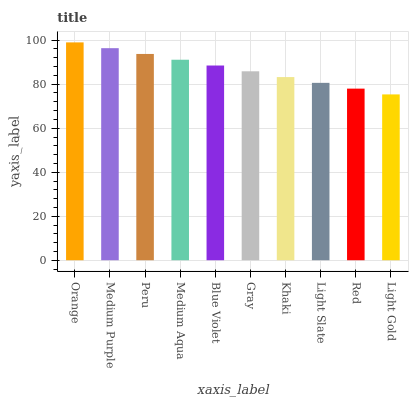Is Light Gold the minimum?
Answer yes or no. Yes. Is Orange the maximum?
Answer yes or no. Yes. Is Medium Purple the minimum?
Answer yes or no. No. Is Medium Purple the maximum?
Answer yes or no. No. Is Orange greater than Medium Purple?
Answer yes or no. Yes. Is Medium Purple less than Orange?
Answer yes or no. Yes. Is Medium Purple greater than Orange?
Answer yes or no. No. Is Orange less than Medium Purple?
Answer yes or no. No. Is Blue Violet the high median?
Answer yes or no. Yes. Is Gray the low median?
Answer yes or no. Yes. Is Light Gold the high median?
Answer yes or no. No. Is Red the low median?
Answer yes or no. No. 